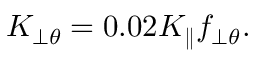<formula> <loc_0><loc_0><loc_500><loc_500>K _ { \perp \theta } = 0 . 0 2 K _ { \| } f _ { \perp \theta } .</formula> 